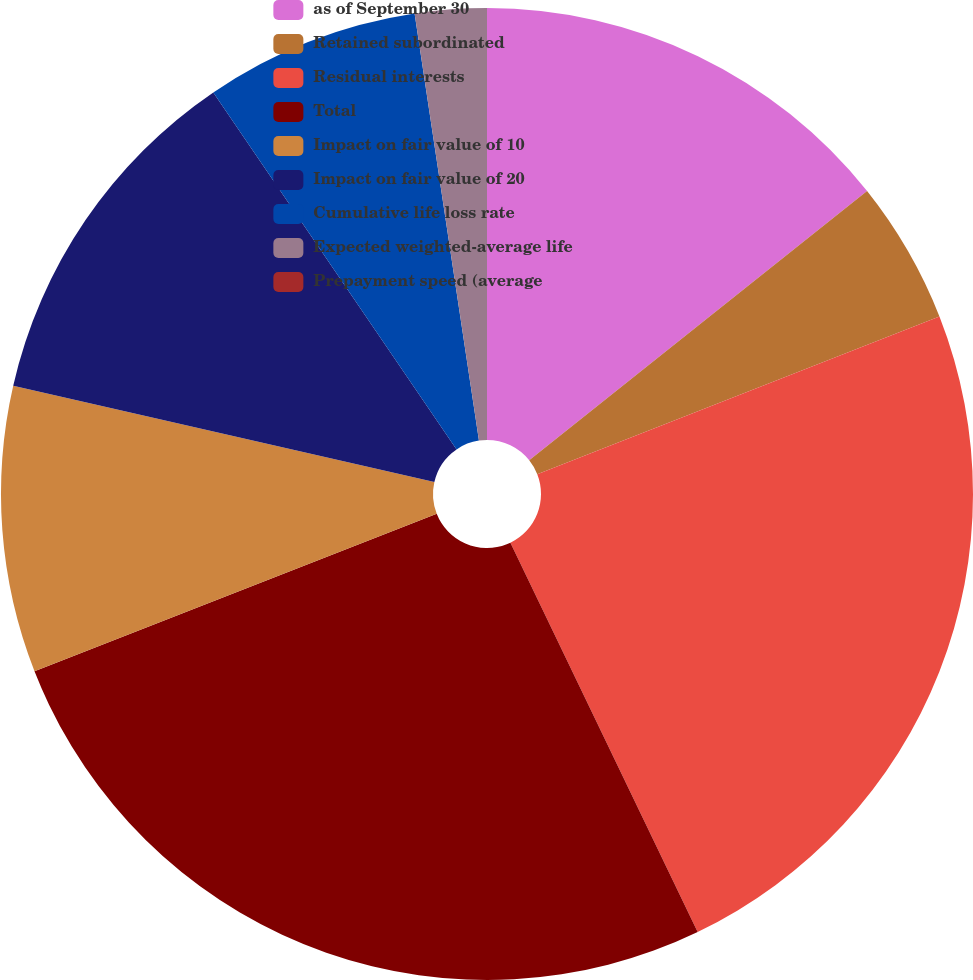Convert chart to OTSL. <chart><loc_0><loc_0><loc_500><loc_500><pie_chart><fcel>as of September 30<fcel>Retained subordinated<fcel>Residual interests<fcel>Total<fcel>Impact on fair value of 10<fcel>Impact on fair value of 20<fcel>Cumulative life loss rate<fcel>Expected weighted-average life<fcel>Prepayment speed (average<nl><fcel>14.29%<fcel>4.76%<fcel>23.81%<fcel>26.19%<fcel>9.52%<fcel>11.9%<fcel>7.14%<fcel>2.38%<fcel>0.0%<nl></chart> 